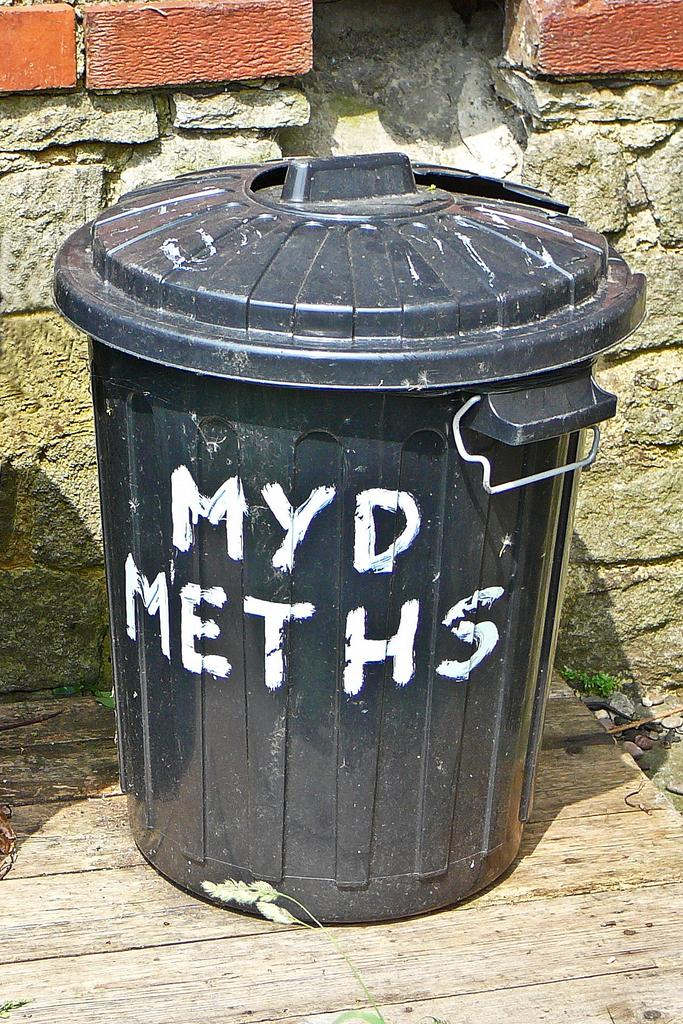<image>
Relay a brief, clear account of the picture shown. A black trash can has the words myd meths painted in white on its center. 